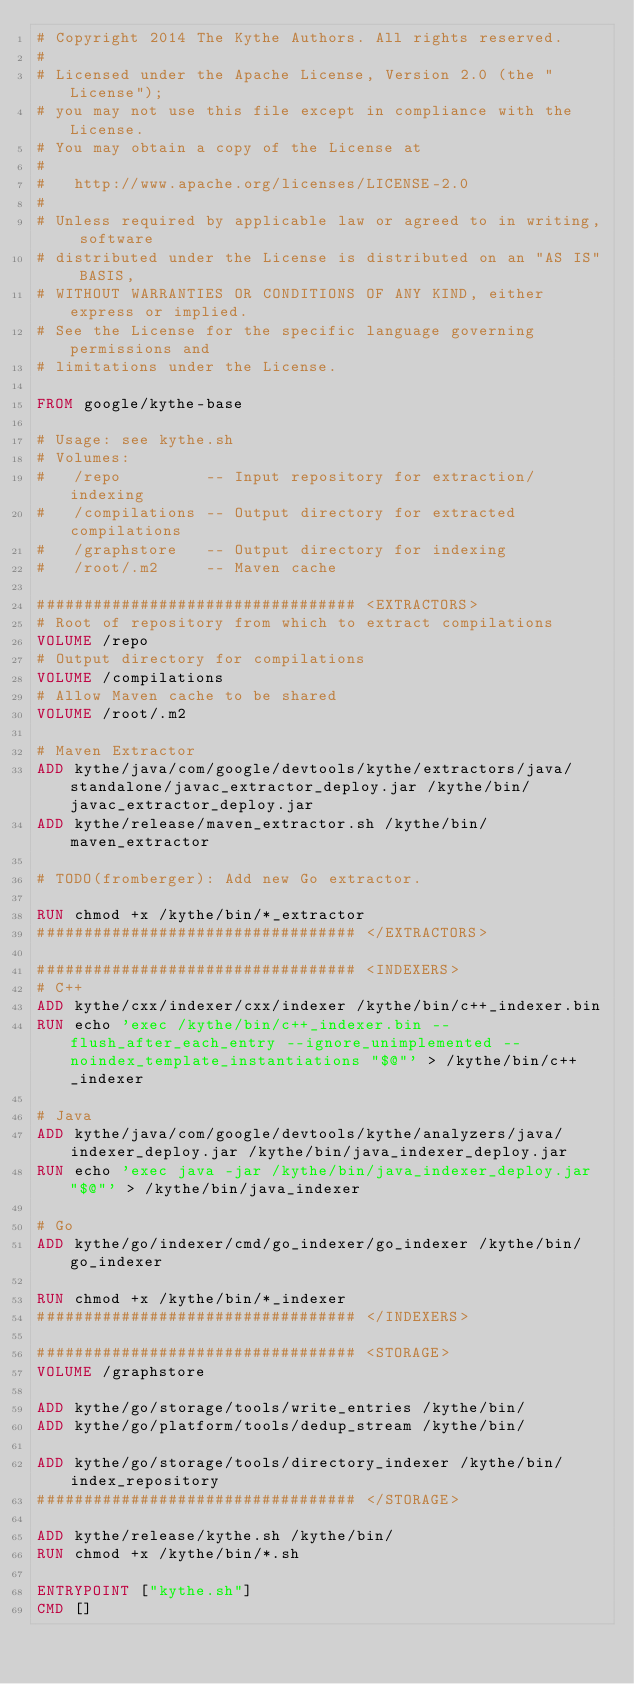Convert code to text. <code><loc_0><loc_0><loc_500><loc_500><_Dockerfile_># Copyright 2014 The Kythe Authors. All rights reserved.
#
# Licensed under the Apache License, Version 2.0 (the "License");
# you may not use this file except in compliance with the License.
# You may obtain a copy of the License at
#
#   http://www.apache.org/licenses/LICENSE-2.0
#
# Unless required by applicable law or agreed to in writing, software
# distributed under the License is distributed on an "AS IS" BASIS,
# WITHOUT WARRANTIES OR CONDITIONS OF ANY KIND, either express or implied.
# See the License for the specific language governing permissions and
# limitations under the License.

FROM google/kythe-base

# Usage: see kythe.sh
# Volumes:
#   /repo         -- Input repository for extraction/indexing
#   /compilations -- Output directory for extracted compilations
#   /graphstore   -- Output directory for indexing
#   /root/.m2     -- Maven cache

################################## <EXTRACTORS>
# Root of repository from which to extract compilations
VOLUME /repo
# Output directory for compilations
VOLUME /compilations
# Allow Maven cache to be shared
VOLUME /root/.m2

# Maven Extractor
ADD kythe/java/com/google/devtools/kythe/extractors/java/standalone/javac_extractor_deploy.jar /kythe/bin/javac_extractor_deploy.jar
ADD kythe/release/maven_extractor.sh /kythe/bin/maven_extractor

# TODO(fromberger): Add new Go extractor.

RUN chmod +x /kythe/bin/*_extractor
################################## </EXTRACTORS>

################################## <INDEXERS>
# C++
ADD kythe/cxx/indexer/cxx/indexer /kythe/bin/c++_indexer.bin
RUN echo 'exec /kythe/bin/c++_indexer.bin --flush_after_each_entry --ignore_unimplemented --noindex_template_instantiations "$@"' > /kythe/bin/c++_indexer

# Java
ADD kythe/java/com/google/devtools/kythe/analyzers/java/indexer_deploy.jar /kythe/bin/java_indexer_deploy.jar
RUN echo 'exec java -jar /kythe/bin/java_indexer_deploy.jar "$@"' > /kythe/bin/java_indexer

# Go
ADD kythe/go/indexer/cmd/go_indexer/go_indexer /kythe/bin/go_indexer

RUN chmod +x /kythe/bin/*_indexer
################################## </INDEXERS>

################################## <STORAGE>
VOLUME /graphstore

ADD kythe/go/storage/tools/write_entries /kythe/bin/
ADD kythe/go/platform/tools/dedup_stream /kythe/bin/

ADD kythe/go/storage/tools/directory_indexer /kythe/bin/index_repository
################################## </STORAGE>

ADD kythe/release/kythe.sh /kythe/bin/
RUN chmod +x /kythe/bin/*.sh

ENTRYPOINT ["kythe.sh"]
CMD []
</code> 